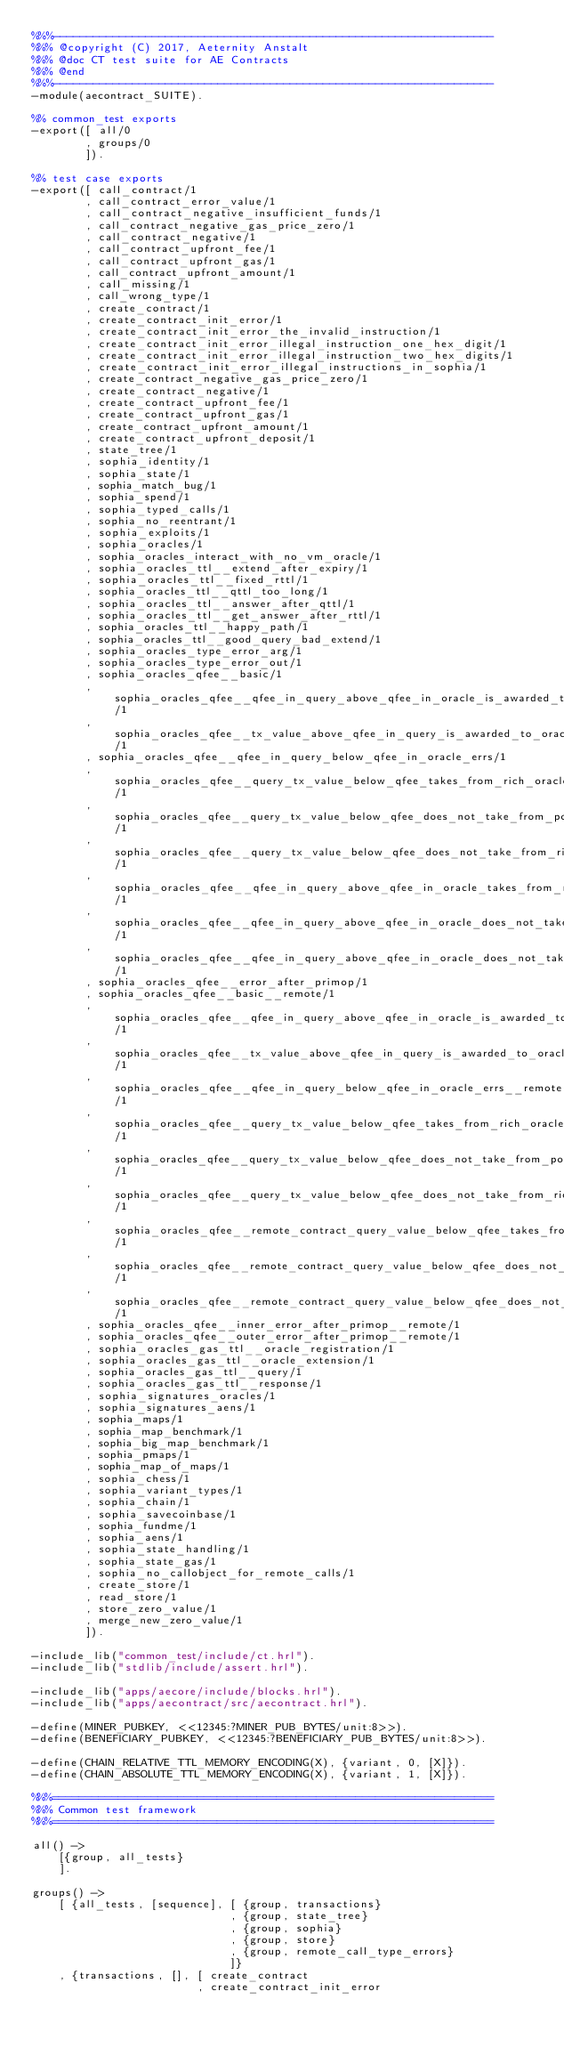<code> <loc_0><loc_0><loc_500><loc_500><_Erlang_>%%%-------------------------------------------------------------------
%%% @copyright (C) 2017, Aeternity Anstalt
%%% @doc CT test suite for AE Contracts
%%% @end
%%%-------------------------------------------------------------------
-module(aecontract_SUITE).

%% common_test exports
-export([ all/0
        , groups/0
        ]).

%% test case exports
-export([ call_contract/1
        , call_contract_error_value/1
        , call_contract_negative_insufficient_funds/1
        , call_contract_negative_gas_price_zero/1
        , call_contract_negative/1
        , call_contract_upfront_fee/1
        , call_contract_upfront_gas/1
        , call_contract_upfront_amount/1
        , call_missing/1
        , call_wrong_type/1
        , create_contract/1
        , create_contract_init_error/1
        , create_contract_init_error_the_invalid_instruction/1
        , create_contract_init_error_illegal_instruction_one_hex_digit/1
        , create_contract_init_error_illegal_instruction_two_hex_digits/1
        , create_contract_init_error_illegal_instructions_in_sophia/1
        , create_contract_negative_gas_price_zero/1
        , create_contract_negative/1
        , create_contract_upfront_fee/1
        , create_contract_upfront_gas/1
        , create_contract_upfront_amount/1
        , create_contract_upfront_deposit/1
        , state_tree/1
        , sophia_identity/1
        , sophia_state/1
        , sophia_match_bug/1
        , sophia_spend/1
        , sophia_typed_calls/1
        , sophia_no_reentrant/1
        , sophia_exploits/1
        , sophia_oracles/1
        , sophia_oracles_interact_with_no_vm_oracle/1
        , sophia_oracles_ttl__extend_after_expiry/1
        , sophia_oracles_ttl__fixed_rttl/1
        , sophia_oracles_ttl__qttl_too_long/1
        , sophia_oracles_ttl__answer_after_qttl/1
        , sophia_oracles_ttl__get_answer_after_rttl/1
        , sophia_oracles_ttl__happy_path/1
        , sophia_oracles_ttl__good_query_bad_extend/1
        , sophia_oracles_type_error_arg/1
        , sophia_oracles_type_error_out/1
        , sophia_oracles_qfee__basic/1
        , sophia_oracles_qfee__qfee_in_query_above_qfee_in_oracle_is_awarded_to_oracle/1
        , sophia_oracles_qfee__tx_value_above_qfee_in_query_is_awarded_to_oracle/1
        , sophia_oracles_qfee__qfee_in_query_below_qfee_in_oracle_errs/1
        , sophia_oracles_qfee__query_tx_value_below_qfee_takes_from_rich_oracle/1
        , sophia_oracles_qfee__query_tx_value_below_qfee_does_not_take_from_poor_oracle/1
        , sophia_oracles_qfee__query_tx_value_below_qfee_does_not_take_from_rich_oracle_thanks_to_contract_check/1
        , sophia_oracles_qfee__qfee_in_query_above_qfee_in_oracle_takes_from_rich_oracle/1
        , sophia_oracles_qfee__qfee_in_query_above_qfee_in_oracle_does_not_take_from_poor_oracle/1
        , sophia_oracles_qfee__qfee_in_query_above_qfee_in_oracle_does_not_take_from_rich_oracle_thanks_to_contract_check/1
        , sophia_oracles_qfee__error_after_primop/1
        , sophia_oracles_qfee__basic__remote/1
        , sophia_oracles_qfee__qfee_in_query_above_qfee_in_oracle_is_awarded_to_oracle__remote/1
        , sophia_oracles_qfee__tx_value_above_qfee_in_query_is_awarded_to_oracle__remote/1
        , sophia_oracles_qfee__qfee_in_query_below_qfee_in_oracle_errs__remote/1
        , sophia_oracles_qfee__query_tx_value_below_qfee_takes_from_rich_oracle__remote/1
        , sophia_oracles_qfee__query_tx_value_below_qfee_does_not_take_from_poor_oracle__remote/1
        , sophia_oracles_qfee__query_tx_value_below_qfee_does_not_take_from_rich_oracle_thanks_to_contract_check__remote/1
        , sophia_oracles_qfee__remote_contract_query_value_below_qfee_takes_from_rich_oracle__remote/1
        , sophia_oracles_qfee__remote_contract_query_value_below_qfee_does_not_take_from_poor_oracle__remote/1
        , sophia_oracles_qfee__remote_contract_query_value_below_qfee_does_not_take_from_rich_oracle_thanks_to_contract_check__remote/1
        , sophia_oracles_qfee__inner_error_after_primop__remote/1
        , sophia_oracles_qfee__outer_error_after_primop__remote/1
        , sophia_oracles_gas_ttl__oracle_registration/1
        , sophia_oracles_gas_ttl__oracle_extension/1
        , sophia_oracles_gas_ttl__query/1
        , sophia_oracles_gas_ttl__response/1
        , sophia_signatures_oracles/1
        , sophia_signatures_aens/1
        , sophia_maps/1
        , sophia_map_benchmark/1
        , sophia_big_map_benchmark/1
        , sophia_pmaps/1
        , sophia_map_of_maps/1
        , sophia_chess/1
        , sophia_variant_types/1
        , sophia_chain/1
        , sophia_savecoinbase/1
        , sophia_fundme/1
        , sophia_aens/1
        , sophia_state_handling/1
        , sophia_state_gas/1
        , sophia_no_callobject_for_remote_calls/1
        , create_store/1
        , read_store/1
        , store_zero_value/1
        , merge_new_zero_value/1
        ]).

-include_lib("common_test/include/ct.hrl").
-include_lib("stdlib/include/assert.hrl").

-include_lib("apps/aecore/include/blocks.hrl").
-include_lib("apps/aecontract/src/aecontract.hrl").

-define(MINER_PUBKEY, <<12345:?MINER_PUB_BYTES/unit:8>>).
-define(BENEFICIARY_PUBKEY, <<12345:?BENEFICIARY_PUB_BYTES/unit:8>>).

-define(CHAIN_RELATIVE_TTL_MEMORY_ENCODING(X), {variant, 0, [X]}).
-define(CHAIN_ABSOLUTE_TTL_MEMORY_ENCODING(X), {variant, 1, [X]}).

%%%===================================================================
%%% Common test framework
%%%===================================================================

all() ->
    [{group, all_tests}
    ].

groups() ->
    [ {all_tests, [sequence], [ {group, transactions}
                              , {group, state_tree}
                              , {group, sophia}
                              , {group, store}
                              , {group, remote_call_type_errors}
                              ]}
    , {transactions, [], [ create_contract
                         , create_contract_init_error</code> 